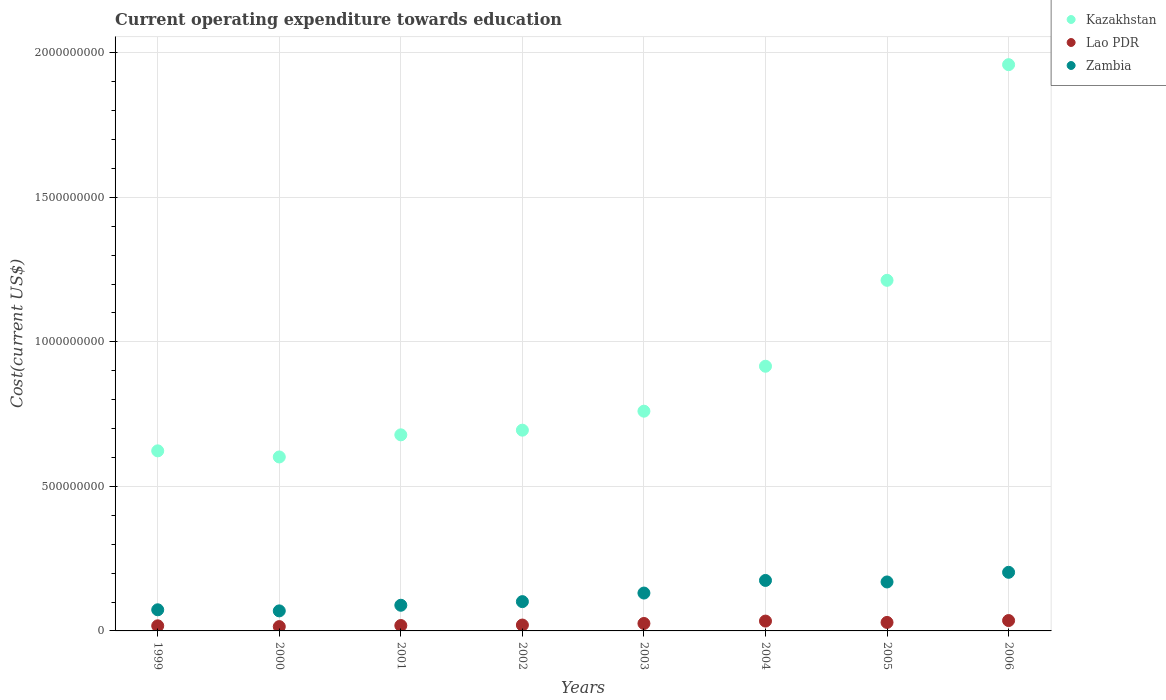Is the number of dotlines equal to the number of legend labels?
Provide a succinct answer. Yes. What is the expenditure towards education in Zambia in 1999?
Your answer should be compact. 7.31e+07. Across all years, what is the maximum expenditure towards education in Lao PDR?
Ensure brevity in your answer.  3.59e+07. Across all years, what is the minimum expenditure towards education in Zambia?
Make the answer very short. 6.93e+07. What is the total expenditure towards education in Kazakhstan in the graph?
Make the answer very short. 7.45e+09. What is the difference between the expenditure towards education in Zambia in 2000 and that in 2001?
Your answer should be very brief. -1.95e+07. What is the difference between the expenditure towards education in Lao PDR in 2004 and the expenditure towards education in Kazakhstan in 2005?
Your answer should be compact. -1.18e+09. What is the average expenditure towards education in Lao PDR per year?
Provide a succinct answer. 2.46e+07. In the year 2006, what is the difference between the expenditure towards education in Kazakhstan and expenditure towards education in Zambia?
Offer a very short reply. 1.76e+09. In how many years, is the expenditure towards education in Zambia greater than 400000000 US$?
Provide a short and direct response. 0. What is the ratio of the expenditure towards education in Zambia in 2000 to that in 2006?
Your answer should be very brief. 0.34. Is the expenditure towards education in Kazakhstan in 2005 less than that in 2006?
Give a very brief answer. Yes. What is the difference between the highest and the second highest expenditure towards education in Lao PDR?
Your answer should be compact. 1.85e+06. What is the difference between the highest and the lowest expenditure towards education in Lao PDR?
Offer a very short reply. 2.09e+07. In how many years, is the expenditure towards education in Zambia greater than the average expenditure towards education in Zambia taken over all years?
Make the answer very short. 4. Is it the case that in every year, the sum of the expenditure towards education in Kazakhstan and expenditure towards education in Lao PDR  is greater than the expenditure towards education in Zambia?
Your answer should be very brief. Yes. Does the expenditure towards education in Zambia monotonically increase over the years?
Your answer should be compact. No. Is the expenditure towards education in Lao PDR strictly less than the expenditure towards education in Kazakhstan over the years?
Give a very brief answer. Yes. What is the difference between two consecutive major ticks on the Y-axis?
Give a very brief answer. 5.00e+08. How are the legend labels stacked?
Offer a very short reply. Vertical. What is the title of the graph?
Make the answer very short. Current operating expenditure towards education. Does "United Kingdom" appear as one of the legend labels in the graph?
Ensure brevity in your answer.  No. What is the label or title of the Y-axis?
Offer a very short reply. Cost(current US$). What is the Cost(current US$) of Kazakhstan in 1999?
Ensure brevity in your answer.  6.23e+08. What is the Cost(current US$) in Lao PDR in 1999?
Ensure brevity in your answer.  1.77e+07. What is the Cost(current US$) in Zambia in 1999?
Offer a very short reply. 7.31e+07. What is the Cost(current US$) in Kazakhstan in 2000?
Provide a succinct answer. 6.02e+08. What is the Cost(current US$) in Lao PDR in 2000?
Provide a short and direct response. 1.49e+07. What is the Cost(current US$) in Zambia in 2000?
Offer a very short reply. 6.93e+07. What is the Cost(current US$) of Kazakhstan in 2001?
Make the answer very short. 6.78e+08. What is the Cost(current US$) in Lao PDR in 2001?
Offer a very short reply. 1.87e+07. What is the Cost(current US$) of Zambia in 2001?
Your response must be concise. 8.88e+07. What is the Cost(current US$) in Kazakhstan in 2002?
Ensure brevity in your answer.  6.95e+08. What is the Cost(current US$) of Lao PDR in 2002?
Provide a succinct answer. 2.03e+07. What is the Cost(current US$) in Zambia in 2002?
Provide a short and direct response. 1.01e+08. What is the Cost(current US$) in Kazakhstan in 2003?
Your response must be concise. 7.60e+08. What is the Cost(current US$) in Lao PDR in 2003?
Offer a very short reply. 2.58e+07. What is the Cost(current US$) in Zambia in 2003?
Provide a succinct answer. 1.31e+08. What is the Cost(current US$) of Kazakhstan in 2004?
Make the answer very short. 9.16e+08. What is the Cost(current US$) of Lao PDR in 2004?
Make the answer very short. 3.40e+07. What is the Cost(current US$) of Zambia in 2004?
Your response must be concise. 1.75e+08. What is the Cost(current US$) in Kazakhstan in 2005?
Give a very brief answer. 1.21e+09. What is the Cost(current US$) of Lao PDR in 2005?
Your response must be concise. 2.94e+07. What is the Cost(current US$) of Zambia in 2005?
Provide a succinct answer. 1.69e+08. What is the Cost(current US$) of Kazakhstan in 2006?
Your response must be concise. 1.96e+09. What is the Cost(current US$) of Lao PDR in 2006?
Provide a short and direct response. 3.59e+07. What is the Cost(current US$) of Zambia in 2006?
Offer a terse response. 2.03e+08. Across all years, what is the maximum Cost(current US$) of Kazakhstan?
Provide a succinct answer. 1.96e+09. Across all years, what is the maximum Cost(current US$) in Lao PDR?
Provide a short and direct response. 3.59e+07. Across all years, what is the maximum Cost(current US$) of Zambia?
Give a very brief answer. 2.03e+08. Across all years, what is the minimum Cost(current US$) in Kazakhstan?
Make the answer very short. 6.02e+08. Across all years, what is the minimum Cost(current US$) in Lao PDR?
Offer a very short reply. 1.49e+07. Across all years, what is the minimum Cost(current US$) of Zambia?
Your response must be concise. 6.93e+07. What is the total Cost(current US$) of Kazakhstan in the graph?
Your answer should be compact. 7.45e+09. What is the total Cost(current US$) of Lao PDR in the graph?
Keep it short and to the point. 1.97e+08. What is the total Cost(current US$) in Zambia in the graph?
Your answer should be compact. 1.01e+09. What is the difference between the Cost(current US$) in Kazakhstan in 1999 and that in 2000?
Provide a short and direct response. 2.11e+07. What is the difference between the Cost(current US$) in Lao PDR in 1999 and that in 2000?
Provide a short and direct response. 2.71e+06. What is the difference between the Cost(current US$) in Zambia in 1999 and that in 2000?
Ensure brevity in your answer.  3.78e+06. What is the difference between the Cost(current US$) in Kazakhstan in 1999 and that in 2001?
Provide a succinct answer. -5.54e+07. What is the difference between the Cost(current US$) of Lao PDR in 1999 and that in 2001?
Ensure brevity in your answer.  -1.04e+06. What is the difference between the Cost(current US$) in Zambia in 1999 and that in 2001?
Provide a succinct answer. -1.57e+07. What is the difference between the Cost(current US$) in Kazakhstan in 1999 and that in 2002?
Offer a very short reply. -7.15e+07. What is the difference between the Cost(current US$) of Lao PDR in 1999 and that in 2002?
Your answer should be very brief. -2.67e+06. What is the difference between the Cost(current US$) in Zambia in 1999 and that in 2002?
Provide a succinct answer. -2.82e+07. What is the difference between the Cost(current US$) in Kazakhstan in 1999 and that in 2003?
Offer a terse response. -1.37e+08. What is the difference between the Cost(current US$) in Lao PDR in 1999 and that in 2003?
Your answer should be very brief. -8.13e+06. What is the difference between the Cost(current US$) in Zambia in 1999 and that in 2003?
Ensure brevity in your answer.  -5.79e+07. What is the difference between the Cost(current US$) of Kazakhstan in 1999 and that in 2004?
Provide a short and direct response. -2.93e+08. What is the difference between the Cost(current US$) in Lao PDR in 1999 and that in 2004?
Give a very brief answer. -1.64e+07. What is the difference between the Cost(current US$) of Zambia in 1999 and that in 2004?
Provide a succinct answer. -1.02e+08. What is the difference between the Cost(current US$) in Kazakhstan in 1999 and that in 2005?
Provide a short and direct response. -5.90e+08. What is the difference between the Cost(current US$) of Lao PDR in 1999 and that in 2005?
Offer a terse response. -1.17e+07. What is the difference between the Cost(current US$) of Zambia in 1999 and that in 2005?
Ensure brevity in your answer.  -9.63e+07. What is the difference between the Cost(current US$) of Kazakhstan in 1999 and that in 2006?
Give a very brief answer. -1.34e+09. What is the difference between the Cost(current US$) in Lao PDR in 1999 and that in 2006?
Provide a succinct answer. -1.82e+07. What is the difference between the Cost(current US$) of Zambia in 1999 and that in 2006?
Give a very brief answer. -1.30e+08. What is the difference between the Cost(current US$) of Kazakhstan in 2000 and that in 2001?
Make the answer very short. -7.65e+07. What is the difference between the Cost(current US$) in Lao PDR in 2000 and that in 2001?
Give a very brief answer. -3.75e+06. What is the difference between the Cost(current US$) of Zambia in 2000 and that in 2001?
Your answer should be compact. -1.95e+07. What is the difference between the Cost(current US$) in Kazakhstan in 2000 and that in 2002?
Your response must be concise. -9.27e+07. What is the difference between the Cost(current US$) of Lao PDR in 2000 and that in 2002?
Make the answer very short. -5.38e+06. What is the difference between the Cost(current US$) of Zambia in 2000 and that in 2002?
Ensure brevity in your answer.  -3.20e+07. What is the difference between the Cost(current US$) of Kazakhstan in 2000 and that in 2003?
Your answer should be compact. -1.58e+08. What is the difference between the Cost(current US$) in Lao PDR in 2000 and that in 2003?
Make the answer very short. -1.08e+07. What is the difference between the Cost(current US$) in Zambia in 2000 and that in 2003?
Ensure brevity in your answer.  -6.17e+07. What is the difference between the Cost(current US$) of Kazakhstan in 2000 and that in 2004?
Provide a short and direct response. -3.14e+08. What is the difference between the Cost(current US$) of Lao PDR in 2000 and that in 2004?
Provide a short and direct response. -1.91e+07. What is the difference between the Cost(current US$) of Zambia in 2000 and that in 2004?
Offer a very short reply. -1.05e+08. What is the difference between the Cost(current US$) of Kazakhstan in 2000 and that in 2005?
Offer a very short reply. -6.11e+08. What is the difference between the Cost(current US$) of Lao PDR in 2000 and that in 2005?
Provide a succinct answer. -1.44e+07. What is the difference between the Cost(current US$) in Zambia in 2000 and that in 2005?
Your answer should be compact. -1.00e+08. What is the difference between the Cost(current US$) of Kazakhstan in 2000 and that in 2006?
Make the answer very short. -1.36e+09. What is the difference between the Cost(current US$) in Lao PDR in 2000 and that in 2006?
Offer a terse response. -2.09e+07. What is the difference between the Cost(current US$) in Zambia in 2000 and that in 2006?
Offer a very short reply. -1.33e+08. What is the difference between the Cost(current US$) of Kazakhstan in 2001 and that in 2002?
Offer a very short reply. -1.62e+07. What is the difference between the Cost(current US$) in Lao PDR in 2001 and that in 2002?
Make the answer very short. -1.63e+06. What is the difference between the Cost(current US$) of Zambia in 2001 and that in 2002?
Offer a very short reply. -1.25e+07. What is the difference between the Cost(current US$) in Kazakhstan in 2001 and that in 2003?
Provide a short and direct response. -8.18e+07. What is the difference between the Cost(current US$) in Lao PDR in 2001 and that in 2003?
Make the answer very short. -7.09e+06. What is the difference between the Cost(current US$) in Zambia in 2001 and that in 2003?
Keep it short and to the point. -4.22e+07. What is the difference between the Cost(current US$) of Kazakhstan in 2001 and that in 2004?
Ensure brevity in your answer.  -2.37e+08. What is the difference between the Cost(current US$) of Lao PDR in 2001 and that in 2004?
Give a very brief answer. -1.53e+07. What is the difference between the Cost(current US$) in Zambia in 2001 and that in 2004?
Offer a terse response. -8.59e+07. What is the difference between the Cost(current US$) of Kazakhstan in 2001 and that in 2005?
Give a very brief answer. -5.35e+08. What is the difference between the Cost(current US$) in Lao PDR in 2001 and that in 2005?
Your answer should be compact. -1.07e+07. What is the difference between the Cost(current US$) in Zambia in 2001 and that in 2005?
Your answer should be very brief. -8.06e+07. What is the difference between the Cost(current US$) of Kazakhstan in 2001 and that in 2006?
Your answer should be very brief. -1.28e+09. What is the difference between the Cost(current US$) in Lao PDR in 2001 and that in 2006?
Offer a very short reply. -1.72e+07. What is the difference between the Cost(current US$) in Zambia in 2001 and that in 2006?
Offer a terse response. -1.14e+08. What is the difference between the Cost(current US$) of Kazakhstan in 2002 and that in 2003?
Your answer should be compact. -6.57e+07. What is the difference between the Cost(current US$) in Lao PDR in 2002 and that in 2003?
Give a very brief answer. -5.46e+06. What is the difference between the Cost(current US$) in Zambia in 2002 and that in 2003?
Provide a short and direct response. -2.97e+07. What is the difference between the Cost(current US$) of Kazakhstan in 2002 and that in 2004?
Provide a succinct answer. -2.21e+08. What is the difference between the Cost(current US$) in Lao PDR in 2002 and that in 2004?
Offer a very short reply. -1.37e+07. What is the difference between the Cost(current US$) in Zambia in 2002 and that in 2004?
Your answer should be very brief. -7.33e+07. What is the difference between the Cost(current US$) in Kazakhstan in 2002 and that in 2005?
Your answer should be very brief. -5.18e+08. What is the difference between the Cost(current US$) of Lao PDR in 2002 and that in 2005?
Give a very brief answer. -9.04e+06. What is the difference between the Cost(current US$) in Zambia in 2002 and that in 2005?
Offer a very short reply. -6.81e+07. What is the difference between the Cost(current US$) of Kazakhstan in 2002 and that in 2006?
Offer a very short reply. -1.26e+09. What is the difference between the Cost(current US$) of Lao PDR in 2002 and that in 2006?
Offer a very short reply. -1.56e+07. What is the difference between the Cost(current US$) in Zambia in 2002 and that in 2006?
Your answer should be very brief. -1.01e+08. What is the difference between the Cost(current US$) of Kazakhstan in 2003 and that in 2004?
Offer a very short reply. -1.56e+08. What is the difference between the Cost(current US$) of Lao PDR in 2003 and that in 2004?
Give a very brief answer. -8.26e+06. What is the difference between the Cost(current US$) of Zambia in 2003 and that in 2004?
Ensure brevity in your answer.  -4.36e+07. What is the difference between the Cost(current US$) in Kazakhstan in 2003 and that in 2005?
Offer a terse response. -4.53e+08. What is the difference between the Cost(current US$) in Lao PDR in 2003 and that in 2005?
Ensure brevity in your answer.  -3.58e+06. What is the difference between the Cost(current US$) of Zambia in 2003 and that in 2005?
Give a very brief answer. -3.84e+07. What is the difference between the Cost(current US$) in Kazakhstan in 2003 and that in 2006?
Make the answer very short. -1.20e+09. What is the difference between the Cost(current US$) in Lao PDR in 2003 and that in 2006?
Offer a terse response. -1.01e+07. What is the difference between the Cost(current US$) of Zambia in 2003 and that in 2006?
Give a very brief answer. -7.18e+07. What is the difference between the Cost(current US$) in Kazakhstan in 2004 and that in 2005?
Your response must be concise. -2.97e+08. What is the difference between the Cost(current US$) of Lao PDR in 2004 and that in 2005?
Offer a terse response. 4.67e+06. What is the difference between the Cost(current US$) in Zambia in 2004 and that in 2005?
Offer a very short reply. 5.27e+06. What is the difference between the Cost(current US$) in Kazakhstan in 2004 and that in 2006?
Provide a succinct answer. -1.04e+09. What is the difference between the Cost(current US$) in Lao PDR in 2004 and that in 2006?
Ensure brevity in your answer.  -1.85e+06. What is the difference between the Cost(current US$) in Zambia in 2004 and that in 2006?
Provide a succinct answer. -2.81e+07. What is the difference between the Cost(current US$) in Kazakhstan in 2005 and that in 2006?
Offer a very short reply. -7.46e+08. What is the difference between the Cost(current US$) in Lao PDR in 2005 and that in 2006?
Your answer should be very brief. -6.52e+06. What is the difference between the Cost(current US$) of Zambia in 2005 and that in 2006?
Your answer should be compact. -3.34e+07. What is the difference between the Cost(current US$) in Kazakhstan in 1999 and the Cost(current US$) in Lao PDR in 2000?
Your response must be concise. 6.08e+08. What is the difference between the Cost(current US$) of Kazakhstan in 1999 and the Cost(current US$) of Zambia in 2000?
Offer a very short reply. 5.54e+08. What is the difference between the Cost(current US$) of Lao PDR in 1999 and the Cost(current US$) of Zambia in 2000?
Keep it short and to the point. -5.17e+07. What is the difference between the Cost(current US$) of Kazakhstan in 1999 and the Cost(current US$) of Lao PDR in 2001?
Your response must be concise. 6.04e+08. What is the difference between the Cost(current US$) in Kazakhstan in 1999 and the Cost(current US$) in Zambia in 2001?
Offer a very short reply. 5.34e+08. What is the difference between the Cost(current US$) in Lao PDR in 1999 and the Cost(current US$) in Zambia in 2001?
Provide a short and direct response. -7.11e+07. What is the difference between the Cost(current US$) in Kazakhstan in 1999 and the Cost(current US$) in Lao PDR in 2002?
Offer a terse response. 6.03e+08. What is the difference between the Cost(current US$) of Kazakhstan in 1999 and the Cost(current US$) of Zambia in 2002?
Provide a succinct answer. 5.22e+08. What is the difference between the Cost(current US$) of Lao PDR in 1999 and the Cost(current US$) of Zambia in 2002?
Keep it short and to the point. -8.37e+07. What is the difference between the Cost(current US$) of Kazakhstan in 1999 and the Cost(current US$) of Lao PDR in 2003?
Keep it short and to the point. 5.97e+08. What is the difference between the Cost(current US$) of Kazakhstan in 1999 and the Cost(current US$) of Zambia in 2003?
Provide a succinct answer. 4.92e+08. What is the difference between the Cost(current US$) in Lao PDR in 1999 and the Cost(current US$) in Zambia in 2003?
Provide a short and direct response. -1.13e+08. What is the difference between the Cost(current US$) in Kazakhstan in 1999 and the Cost(current US$) in Lao PDR in 2004?
Your response must be concise. 5.89e+08. What is the difference between the Cost(current US$) of Kazakhstan in 1999 and the Cost(current US$) of Zambia in 2004?
Give a very brief answer. 4.48e+08. What is the difference between the Cost(current US$) in Lao PDR in 1999 and the Cost(current US$) in Zambia in 2004?
Offer a very short reply. -1.57e+08. What is the difference between the Cost(current US$) of Kazakhstan in 1999 and the Cost(current US$) of Lao PDR in 2005?
Make the answer very short. 5.94e+08. What is the difference between the Cost(current US$) of Kazakhstan in 1999 and the Cost(current US$) of Zambia in 2005?
Make the answer very short. 4.54e+08. What is the difference between the Cost(current US$) in Lao PDR in 1999 and the Cost(current US$) in Zambia in 2005?
Your answer should be very brief. -1.52e+08. What is the difference between the Cost(current US$) in Kazakhstan in 1999 and the Cost(current US$) in Lao PDR in 2006?
Offer a terse response. 5.87e+08. What is the difference between the Cost(current US$) of Kazakhstan in 1999 and the Cost(current US$) of Zambia in 2006?
Provide a short and direct response. 4.20e+08. What is the difference between the Cost(current US$) of Lao PDR in 1999 and the Cost(current US$) of Zambia in 2006?
Your answer should be compact. -1.85e+08. What is the difference between the Cost(current US$) of Kazakhstan in 2000 and the Cost(current US$) of Lao PDR in 2001?
Provide a short and direct response. 5.83e+08. What is the difference between the Cost(current US$) in Kazakhstan in 2000 and the Cost(current US$) in Zambia in 2001?
Your answer should be very brief. 5.13e+08. What is the difference between the Cost(current US$) of Lao PDR in 2000 and the Cost(current US$) of Zambia in 2001?
Your answer should be very brief. -7.39e+07. What is the difference between the Cost(current US$) of Kazakhstan in 2000 and the Cost(current US$) of Lao PDR in 2002?
Ensure brevity in your answer.  5.82e+08. What is the difference between the Cost(current US$) of Kazakhstan in 2000 and the Cost(current US$) of Zambia in 2002?
Offer a very short reply. 5.01e+08. What is the difference between the Cost(current US$) of Lao PDR in 2000 and the Cost(current US$) of Zambia in 2002?
Provide a short and direct response. -8.64e+07. What is the difference between the Cost(current US$) in Kazakhstan in 2000 and the Cost(current US$) in Lao PDR in 2003?
Your response must be concise. 5.76e+08. What is the difference between the Cost(current US$) of Kazakhstan in 2000 and the Cost(current US$) of Zambia in 2003?
Keep it short and to the point. 4.71e+08. What is the difference between the Cost(current US$) in Lao PDR in 2000 and the Cost(current US$) in Zambia in 2003?
Provide a succinct answer. -1.16e+08. What is the difference between the Cost(current US$) in Kazakhstan in 2000 and the Cost(current US$) in Lao PDR in 2004?
Offer a terse response. 5.68e+08. What is the difference between the Cost(current US$) in Kazakhstan in 2000 and the Cost(current US$) in Zambia in 2004?
Provide a short and direct response. 4.27e+08. What is the difference between the Cost(current US$) of Lao PDR in 2000 and the Cost(current US$) of Zambia in 2004?
Give a very brief answer. -1.60e+08. What is the difference between the Cost(current US$) of Kazakhstan in 2000 and the Cost(current US$) of Lao PDR in 2005?
Give a very brief answer. 5.73e+08. What is the difference between the Cost(current US$) of Kazakhstan in 2000 and the Cost(current US$) of Zambia in 2005?
Give a very brief answer. 4.32e+08. What is the difference between the Cost(current US$) of Lao PDR in 2000 and the Cost(current US$) of Zambia in 2005?
Offer a very short reply. -1.54e+08. What is the difference between the Cost(current US$) of Kazakhstan in 2000 and the Cost(current US$) of Lao PDR in 2006?
Offer a very short reply. 5.66e+08. What is the difference between the Cost(current US$) in Kazakhstan in 2000 and the Cost(current US$) in Zambia in 2006?
Your response must be concise. 3.99e+08. What is the difference between the Cost(current US$) in Lao PDR in 2000 and the Cost(current US$) in Zambia in 2006?
Offer a very short reply. -1.88e+08. What is the difference between the Cost(current US$) in Kazakhstan in 2001 and the Cost(current US$) in Lao PDR in 2002?
Keep it short and to the point. 6.58e+08. What is the difference between the Cost(current US$) of Kazakhstan in 2001 and the Cost(current US$) of Zambia in 2002?
Offer a very short reply. 5.77e+08. What is the difference between the Cost(current US$) in Lao PDR in 2001 and the Cost(current US$) in Zambia in 2002?
Provide a succinct answer. -8.27e+07. What is the difference between the Cost(current US$) in Kazakhstan in 2001 and the Cost(current US$) in Lao PDR in 2003?
Provide a short and direct response. 6.53e+08. What is the difference between the Cost(current US$) of Kazakhstan in 2001 and the Cost(current US$) of Zambia in 2003?
Your response must be concise. 5.47e+08. What is the difference between the Cost(current US$) in Lao PDR in 2001 and the Cost(current US$) in Zambia in 2003?
Ensure brevity in your answer.  -1.12e+08. What is the difference between the Cost(current US$) in Kazakhstan in 2001 and the Cost(current US$) in Lao PDR in 2004?
Keep it short and to the point. 6.44e+08. What is the difference between the Cost(current US$) of Kazakhstan in 2001 and the Cost(current US$) of Zambia in 2004?
Give a very brief answer. 5.04e+08. What is the difference between the Cost(current US$) in Lao PDR in 2001 and the Cost(current US$) in Zambia in 2004?
Your answer should be compact. -1.56e+08. What is the difference between the Cost(current US$) of Kazakhstan in 2001 and the Cost(current US$) of Lao PDR in 2005?
Make the answer very short. 6.49e+08. What is the difference between the Cost(current US$) in Kazakhstan in 2001 and the Cost(current US$) in Zambia in 2005?
Your response must be concise. 5.09e+08. What is the difference between the Cost(current US$) in Lao PDR in 2001 and the Cost(current US$) in Zambia in 2005?
Your answer should be compact. -1.51e+08. What is the difference between the Cost(current US$) in Kazakhstan in 2001 and the Cost(current US$) in Lao PDR in 2006?
Your response must be concise. 6.43e+08. What is the difference between the Cost(current US$) of Kazakhstan in 2001 and the Cost(current US$) of Zambia in 2006?
Ensure brevity in your answer.  4.76e+08. What is the difference between the Cost(current US$) of Lao PDR in 2001 and the Cost(current US$) of Zambia in 2006?
Your answer should be compact. -1.84e+08. What is the difference between the Cost(current US$) in Kazakhstan in 2002 and the Cost(current US$) in Lao PDR in 2003?
Give a very brief answer. 6.69e+08. What is the difference between the Cost(current US$) of Kazakhstan in 2002 and the Cost(current US$) of Zambia in 2003?
Offer a very short reply. 5.64e+08. What is the difference between the Cost(current US$) of Lao PDR in 2002 and the Cost(current US$) of Zambia in 2003?
Your response must be concise. -1.11e+08. What is the difference between the Cost(current US$) of Kazakhstan in 2002 and the Cost(current US$) of Lao PDR in 2004?
Provide a short and direct response. 6.61e+08. What is the difference between the Cost(current US$) in Kazakhstan in 2002 and the Cost(current US$) in Zambia in 2004?
Make the answer very short. 5.20e+08. What is the difference between the Cost(current US$) of Lao PDR in 2002 and the Cost(current US$) of Zambia in 2004?
Provide a short and direct response. -1.54e+08. What is the difference between the Cost(current US$) of Kazakhstan in 2002 and the Cost(current US$) of Lao PDR in 2005?
Provide a short and direct response. 6.65e+08. What is the difference between the Cost(current US$) in Kazakhstan in 2002 and the Cost(current US$) in Zambia in 2005?
Give a very brief answer. 5.25e+08. What is the difference between the Cost(current US$) in Lao PDR in 2002 and the Cost(current US$) in Zambia in 2005?
Your answer should be very brief. -1.49e+08. What is the difference between the Cost(current US$) in Kazakhstan in 2002 and the Cost(current US$) in Lao PDR in 2006?
Provide a short and direct response. 6.59e+08. What is the difference between the Cost(current US$) in Kazakhstan in 2002 and the Cost(current US$) in Zambia in 2006?
Make the answer very short. 4.92e+08. What is the difference between the Cost(current US$) of Lao PDR in 2002 and the Cost(current US$) of Zambia in 2006?
Ensure brevity in your answer.  -1.82e+08. What is the difference between the Cost(current US$) in Kazakhstan in 2003 and the Cost(current US$) in Lao PDR in 2004?
Provide a succinct answer. 7.26e+08. What is the difference between the Cost(current US$) of Kazakhstan in 2003 and the Cost(current US$) of Zambia in 2004?
Provide a short and direct response. 5.86e+08. What is the difference between the Cost(current US$) of Lao PDR in 2003 and the Cost(current US$) of Zambia in 2004?
Make the answer very short. -1.49e+08. What is the difference between the Cost(current US$) of Kazakhstan in 2003 and the Cost(current US$) of Lao PDR in 2005?
Provide a succinct answer. 7.31e+08. What is the difference between the Cost(current US$) of Kazakhstan in 2003 and the Cost(current US$) of Zambia in 2005?
Give a very brief answer. 5.91e+08. What is the difference between the Cost(current US$) in Lao PDR in 2003 and the Cost(current US$) in Zambia in 2005?
Provide a short and direct response. -1.44e+08. What is the difference between the Cost(current US$) of Kazakhstan in 2003 and the Cost(current US$) of Lao PDR in 2006?
Make the answer very short. 7.24e+08. What is the difference between the Cost(current US$) in Kazakhstan in 2003 and the Cost(current US$) in Zambia in 2006?
Keep it short and to the point. 5.57e+08. What is the difference between the Cost(current US$) in Lao PDR in 2003 and the Cost(current US$) in Zambia in 2006?
Your response must be concise. -1.77e+08. What is the difference between the Cost(current US$) in Kazakhstan in 2004 and the Cost(current US$) in Lao PDR in 2005?
Your answer should be very brief. 8.86e+08. What is the difference between the Cost(current US$) in Kazakhstan in 2004 and the Cost(current US$) in Zambia in 2005?
Give a very brief answer. 7.46e+08. What is the difference between the Cost(current US$) of Lao PDR in 2004 and the Cost(current US$) of Zambia in 2005?
Provide a short and direct response. -1.35e+08. What is the difference between the Cost(current US$) in Kazakhstan in 2004 and the Cost(current US$) in Lao PDR in 2006?
Your answer should be compact. 8.80e+08. What is the difference between the Cost(current US$) in Kazakhstan in 2004 and the Cost(current US$) in Zambia in 2006?
Give a very brief answer. 7.13e+08. What is the difference between the Cost(current US$) of Lao PDR in 2004 and the Cost(current US$) of Zambia in 2006?
Provide a succinct answer. -1.69e+08. What is the difference between the Cost(current US$) of Kazakhstan in 2005 and the Cost(current US$) of Lao PDR in 2006?
Your answer should be compact. 1.18e+09. What is the difference between the Cost(current US$) of Kazakhstan in 2005 and the Cost(current US$) of Zambia in 2006?
Your answer should be compact. 1.01e+09. What is the difference between the Cost(current US$) in Lao PDR in 2005 and the Cost(current US$) in Zambia in 2006?
Your answer should be very brief. -1.73e+08. What is the average Cost(current US$) in Kazakhstan per year?
Give a very brief answer. 9.31e+08. What is the average Cost(current US$) in Lao PDR per year?
Your answer should be compact. 2.46e+07. What is the average Cost(current US$) of Zambia per year?
Offer a very short reply. 1.26e+08. In the year 1999, what is the difference between the Cost(current US$) of Kazakhstan and Cost(current US$) of Lao PDR?
Your response must be concise. 6.05e+08. In the year 1999, what is the difference between the Cost(current US$) of Kazakhstan and Cost(current US$) of Zambia?
Give a very brief answer. 5.50e+08. In the year 1999, what is the difference between the Cost(current US$) in Lao PDR and Cost(current US$) in Zambia?
Your answer should be compact. -5.55e+07. In the year 2000, what is the difference between the Cost(current US$) in Kazakhstan and Cost(current US$) in Lao PDR?
Provide a succinct answer. 5.87e+08. In the year 2000, what is the difference between the Cost(current US$) of Kazakhstan and Cost(current US$) of Zambia?
Offer a very short reply. 5.33e+08. In the year 2000, what is the difference between the Cost(current US$) in Lao PDR and Cost(current US$) in Zambia?
Keep it short and to the point. -5.44e+07. In the year 2001, what is the difference between the Cost(current US$) in Kazakhstan and Cost(current US$) in Lao PDR?
Offer a very short reply. 6.60e+08. In the year 2001, what is the difference between the Cost(current US$) in Kazakhstan and Cost(current US$) in Zambia?
Your response must be concise. 5.90e+08. In the year 2001, what is the difference between the Cost(current US$) in Lao PDR and Cost(current US$) in Zambia?
Offer a very short reply. -7.01e+07. In the year 2002, what is the difference between the Cost(current US$) in Kazakhstan and Cost(current US$) in Lao PDR?
Provide a succinct answer. 6.74e+08. In the year 2002, what is the difference between the Cost(current US$) in Kazakhstan and Cost(current US$) in Zambia?
Your answer should be very brief. 5.93e+08. In the year 2002, what is the difference between the Cost(current US$) in Lao PDR and Cost(current US$) in Zambia?
Ensure brevity in your answer.  -8.10e+07. In the year 2003, what is the difference between the Cost(current US$) of Kazakhstan and Cost(current US$) of Lao PDR?
Provide a short and direct response. 7.34e+08. In the year 2003, what is the difference between the Cost(current US$) of Kazakhstan and Cost(current US$) of Zambia?
Give a very brief answer. 6.29e+08. In the year 2003, what is the difference between the Cost(current US$) in Lao PDR and Cost(current US$) in Zambia?
Your answer should be very brief. -1.05e+08. In the year 2004, what is the difference between the Cost(current US$) in Kazakhstan and Cost(current US$) in Lao PDR?
Your response must be concise. 8.82e+08. In the year 2004, what is the difference between the Cost(current US$) in Kazakhstan and Cost(current US$) in Zambia?
Your response must be concise. 7.41e+08. In the year 2004, what is the difference between the Cost(current US$) of Lao PDR and Cost(current US$) of Zambia?
Your answer should be very brief. -1.41e+08. In the year 2005, what is the difference between the Cost(current US$) in Kazakhstan and Cost(current US$) in Lao PDR?
Provide a short and direct response. 1.18e+09. In the year 2005, what is the difference between the Cost(current US$) in Kazakhstan and Cost(current US$) in Zambia?
Offer a terse response. 1.04e+09. In the year 2005, what is the difference between the Cost(current US$) of Lao PDR and Cost(current US$) of Zambia?
Offer a terse response. -1.40e+08. In the year 2006, what is the difference between the Cost(current US$) of Kazakhstan and Cost(current US$) of Lao PDR?
Provide a succinct answer. 1.92e+09. In the year 2006, what is the difference between the Cost(current US$) of Kazakhstan and Cost(current US$) of Zambia?
Ensure brevity in your answer.  1.76e+09. In the year 2006, what is the difference between the Cost(current US$) in Lao PDR and Cost(current US$) in Zambia?
Your answer should be very brief. -1.67e+08. What is the ratio of the Cost(current US$) in Kazakhstan in 1999 to that in 2000?
Make the answer very short. 1.04. What is the ratio of the Cost(current US$) in Lao PDR in 1999 to that in 2000?
Offer a terse response. 1.18. What is the ratio of the Cost(current US$) of Zambia in 1999 to that in 2000?
Offer a terse response. 1.05. What is the ratio of the Cost(current US$) in Kazakhstan in 1999 to that in 2001?
Provide a short and direct response. 0.92. What is the ratio of the Cost(current US$) in Zambia in 1999 to that in 2001?
Offer a very short reply. 0.82. What is the ratio of the Cost(current US$) in Kazakhstan in 1999 to that in 2002?
Ensure brevity in your answer.  0.9. What is the ratio of the Cost(current US$) of Lao PDR in 1999 to that in 2002?
Provide a short and direct response. 0.87. What is the ratio of the Cost(current US$) in Zambia in 1999 to that in 2002?
Keep it short and to the point. 0.72. What is the ratio of the Cost(current US$) in Kazakhstan in 1999 to that in 2003?
Give a very brief answer. 0.82. What is the ratio of the Cost(current US$) in Lao PDR in 1999 to that in 2003?
Offer a terse response. 0.68. What is the ratio of the Cost(current US$) of Zambia in 1999 to that in 2003?
Give a very brief answer. 0.56. What is the ratio of the Cost(current US$) of Kazakhstan in 1999 to that in 2004?
Provide a succinct answer. 0.68. What is the ratio of the Cost(current US$) of Lao PDR in 1999 to that in 2004?
Ensure brevity in your answer.  0.52. What is the ratio of the Cost(current US$) of Zambia in 1999 to that in 2004?
Offer a very short reply. 0.42. What is the ratio of the Cost(current US$) in Kazakhstan in 1999 to that in 2005?
Provide a succinct answer. 0.51. What is the ratio of the Cost(current US$) in Lao PDR in 1999 to that in 2005?
Provide a succinct answer. 0.6. What is the ratio of the Cost(current US$) in Zambia in 1999 to that in 2005?
Offer a very short reply. 0.43. What is the ratio of the Cost(current US$) of Kazakhstan in 1999 to that in 2006?
Offer a terse response. 0.32. What is the ratio of the Cost(current US$) in Lao PDR in 1999 to that in 2006?
Offer a very short reply. 0.49. What is the ratio of the Cost(current US$) in Zambia in 1999 to that in 2006?
Your answer should be very brief. 0.36. What is the ratio of the Cost(current US$) in Kazakhstan in 2000 to that in 2001?
Provide a succinct answer. 0.89. What is the ratio of the Cost(current US$) in Lao PDR in 2000 to that in 2001?
Give a very brief answer. 0.8. What is the ratio of the Cost(current US$) of Zambia in 2000 to that in 2001?
Give a very brief answer. 0.78. What is the ratio of the Cost(current US$) in Kazakhstan in 2000 to that in 2002?
Keep it short and to the point. 0.87. What is the ratio of the Cost(current US$) of Lao PDR in 2000 to that in 2002?
Ensure brevity in your answer.  0.74. What is the ratio of the Cost(current US$) in Zambia in 2000 to that in 2002?
Keep it short and to the point. 0.68. What is the ratio of the Cost(current US$) in Kazakhstan in 2000 to that in 2003?
Provide a short and direct response. 0.79. What is the ratio of the Cost(current US$) of Lao PDR in 2000 to that in 2003?
Offer a terse response. 0.58. What is the ratio of the Cost(current US$) in Zambia in 2000 to that in 2003?
Your response must be concise. 0.53. What is the ratio of the Cost(current US$) in Kazakhstan in 2000 to that in 2004?
Provide a short and direct response. 0.66. What is the ratio of the Cost(current US$) of Lao PDR in 2000 to that in 2004?
Your answer should be compact. 0.44. What is the ratio of the Cost(current US$) of Zambia in 2000 to that in 2004?
Offer a terse response. 0.4. What is the ratio of the Cost(current US$) of Kazakhstan in 2000 to that in 2005?
Keep it short and to the point. 0.5. What is the ratio of the Cost(current US$) of Lao PDR in 2000 to that in 2005?
Keep it short and to the point. 0.51. What is the ratio of the Cost(current US$) of Zambia in 2000 to that in 2005?
Offer a very short reply. 0.41. What is the ratio of the Cost(current US$) in Kazakhstan in 2000 to that in 2006?
Keep it short and to the point. 0.31. What is the ratio of the Cost(current US$) in Lao PDR in 2000 to that in 2006?
Your answer should be compact. 0.42. What is the ratio of the Cost(current US$) of Zambia in 2000 to that in 2006?
Ensure brevity in your answer.  0.34. What is the ratio of the Cost(current US$) of Kazakhstan in 2001 to that in 2002?
Give a very brief answer. 0.98. What is the ratio of the Cost(current US$) of Lao PDR in 2001 to that in 2002?
Your response must be concise. 0.92. What is the ratio of the Cost(current US$) in Zambia in 2001 to that in 2002?
Offer a very short reply. 0.88. What is the ratio of the Cost(current US$) in Kazakhstan in 2001 to that in 2003?
Give a very brief answer. 0.89. What is the ratio of the Cost(current US$) of Lao PDR in 2001 to that in 2003?
Provide a succinct answer. 0.73. What is the ratio of the Cost(current US$) in Zambia in 2001 to that in 2003?
Give a very brief answer. 0.68. What is the ratio of the Cost(current US$) in Kazakhstan in 2001 to that in 2004?
Your answer should be very brief. 0.74. What is the ratio of the Cost(current US$) of Lao PDR in 2001 to that in 2004?
Your response must be concise. 0.55. What is the ratio of the Cost(current US$) in Zambia in 2001 to that in 2004?
Offer a very short reply. 0.51. What is the ratio of the Cost(current US$) in Kazakhstan in 2001 to that in 2005?
Make the answer very short. 0.56. What is the ratio of the Cost(current US$) in Lao PDR in 2001 to that in 2005?
Your response must be concise. 0.64. What is the ratio of the Cost(current US$) in Zambia in 2001 to that in 2005?
Offer a terse response. 0.52. What is the ratio of the Cost(current US$) of Kazakhstan in 2001 to that in 2006?
Offer a very short reply. 0.35. What is the ratio of the Cost(current US$) of Lao PDR in 2001 to that in 2006?
Your response must be concise. 0.52. What is the ratio of the Cost(current US$) in Zambia in 2001 to that in 2006?
Provide a succinct answer. 0.44. What is the ratio of the Cost(current US$) of Kazakhstan in 2002 to that in 2003?
Your answer should be compact. 0.91. What is the ratio of the Cost(current US$) of Lao PDR in 2002 to that in 2003?
Provide a short and direct response. 0.79. What is the ratio of the Cost(current US$) in Zambia in 2002 to that in 2003?
Your answer should be compact. 0.77. What is the ratio of the Cost(current US$) in Kazakhstan in 2002 to that in 2004?
Give a very brief answer. 0.76. What is the ratio of the Cost(current US$) of Lao PDR in 2002 to that in 2004?
Your answer should be compact. 0.6. What is the ratio of the Cost(current US$) in Zambia in 2002 to that in 2004?
Your response must be concise. 0.58. What is the ratio of the Cost(current US$) in Kazakhstan in 2002 to that in 2005?
Your response must be concise. 0.57. What is the ratio of the Cost(current US$) of Lao PDR in 2002 to that in 2005?
Offer a very short reply. 0.69. What is the ratio of the Cost(current US$) in Zambia in 2002 to that in 2005?
Provide a succinct answer. 0.6. What is the ratio of the Cost(current US$) of Kazakhstan in 2002 to that in 2006?
Ensure brevity in your answer.  0.35. What is the ratio of the Cost(current US$) of Lao PDR in 2002 to that in 2006?
Keep it short and to the point. 0.57. What is the ratio of the Cost(current US$) of Zambia in 2002 to that in 2006?
Your response must be concise. 0.5. What is the ratio of the Cost(current US$) of Kazakhstan in 2003 to that in 2004?
Provide a short and direct response. 0.83. What is the ratio of the Cost(current US$) of Lao PDR in 2003 to that in 2004?
Your answer should be compact. 0.76. What is the ratio of the Cost(current US$) of Zambia in 2003 to that in 2004?
Your response must be concise. 0.75. What is the ratio of the Cost(current US$) of Kazakhstan in 2003 to that in 2005?
Your response must be concise. 0.63. What is the ratio of the Cost(current US$) in Lao PDR in 2003 to that in 2005?
Provide a succinct answer. 0.88. What is the ratio of the Cost(current US$) of Zambia in 2003 to that in 2005?
Ensure brevity in your answer.  0.77. What is the ratio of the Cost(current US$) of Kazakhstan in 2003 to that in 2006?
Offer a very short reply. 0.39. What is the ratio of the Cost(current US$) in Lao PDR in 2003 to that in 2006?
Ensure brevity in your answer.  0.72. What is the ratio of the Cost(current US$) of Zambia in 2003 to that in 2006?
Ensure brevity in your answer.  0.65. What is the ratio of the Cost(current US$) in Kazakhstan in 2004 to that in 2005?
Give a very brief answer. 0.75. What is the ratio of the Cost(current US$) in Lao PDR in 2004 to that in 2005?
Provide a short and direct response. 1.16. What is the ratio of the Cost(current US$) in Zambia in 2004 to that in 2005?
Offer a terse response. 1.03. What is the ratio of the Cost(current US$) in Kazakhstan in 2004 to that in 2006?
Provide a succinct answer. 0.47. What is the ratio of the Cost(current US$) in Lao PDR in 2004 to that in 2006?
Ensure brevity in your answer.  0.95. What is the ratio of the Cost(current US$) in Zambia in 2004 to that in 2006?
Keep it short and to the point. 0.86. What is the ratio of the Cost(current US$) of Kazakhstan in 2005 to that in 2006?
Keep it short and to the point. 0.62. What is the ratio of the Cost(current US$) in Lao PDR in 2005 to that in 2006?
Your answer should be compact. 0.82. What is the ratio of the Cost(current US$) of Zambia in 2005 to that in 2006?
Keep it short and to the point. 0.84. What is the difference between the highest and the second highest Cost(current US$) of Kazakhstan?
Ensure brevity in your answer.  7.46e+08. What is the difference between the highest and the second highest Cost(current US$) in Lao PDR?
Keep it short and to the point. 1.85e+06. What is the difference between the highest and the second highest Cost(current US$) in Zambia?
Ensure brevity in your answer.  2.81e+07. What is the difference between the highest and the lowest Cost(current US$) in Kazakhstan?
Your answer should be very brief. 1.36e+09. What is the difference between the highest and the lowest Cost(current US$) in Lao PDR?
Offer a very short reply. 2.09e+07. What is the difference between the highest and the lowest Cost(current US$) of Zambia?
Make the answer very short. 1.33e+08. 